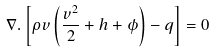Convert formula to latex. <formula><loc_0><loc_0><loc_500><loc_500>\nabla . \left [ \rho { v } \left ( \frac { v ^ { 2 } } { 2 } + h + \phi \right ) - { q } \right ] = 0</formula> 